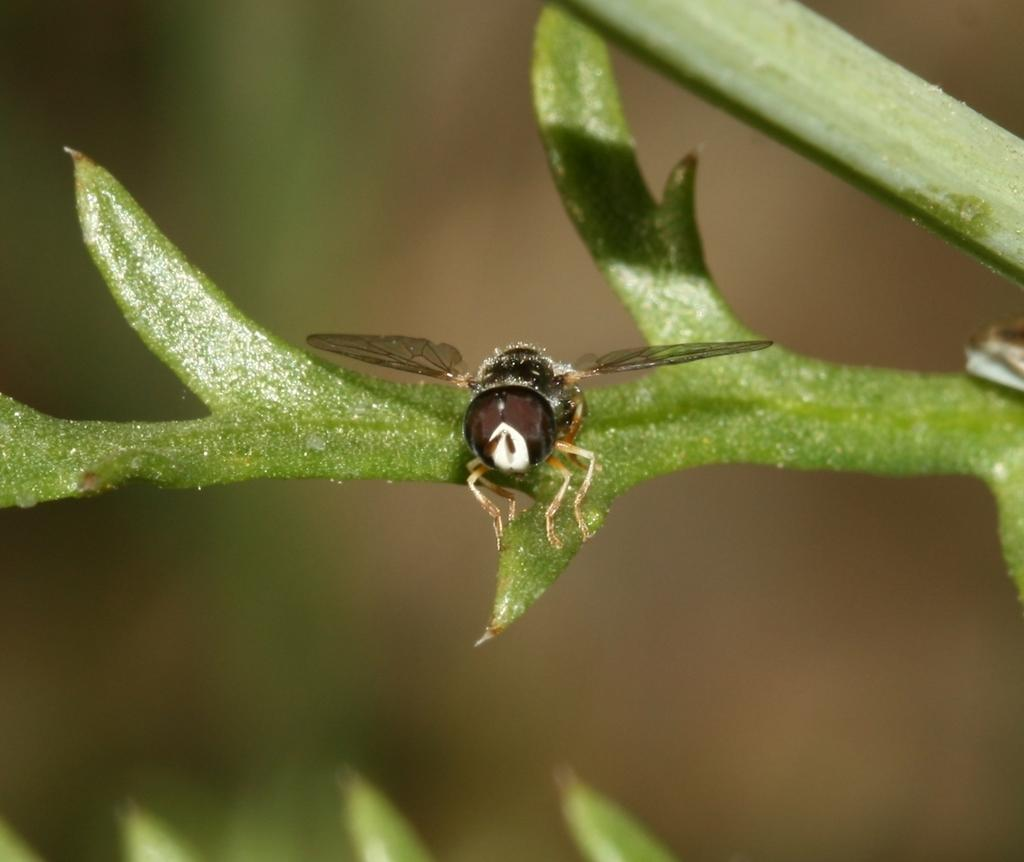What is the main subject of the image? The main subject of the image is a fly on a leaf. Can you describe the background of the image? The background of the image is blurred. How many sheep are visible in the image? There are no sheep present in the image; it features a fly on a leaf. What type of pen is being used by the fly to write on the leaf? There is no pen present in the image, as flies do not have the ability to write. 